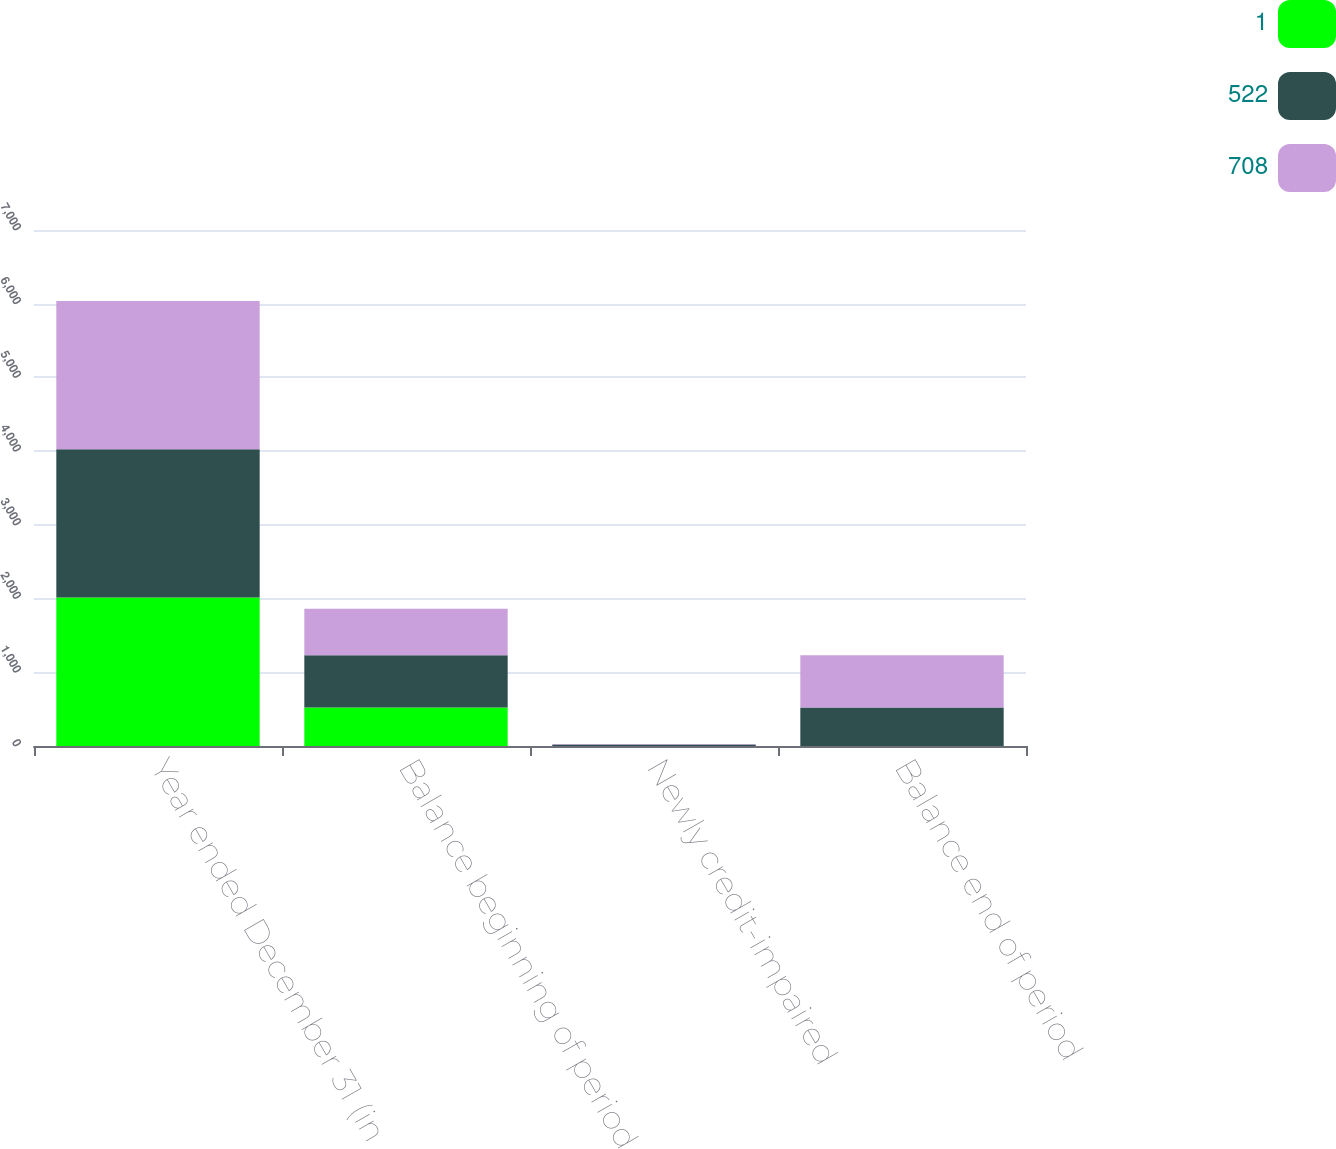Convert chart. <chart><loc_0><loc_0><loc_500><loc_500><stacked_bar_chart><ecel><fcel>Year ended December 31 (in<fcel>Balance beginning of period<fcel>Newly credit-impaired<fcel>Balance end of period<nl><fcel>1<fcel>2013<fcel>522<fcel>1<fcel>1<nl><fcel>522<fcel>2012<fcel>708<fcel>21<fcel>522<nl><fcel>708<fcel>2011<fcel>632<fcel>4<fcel>708<nl></chart> 